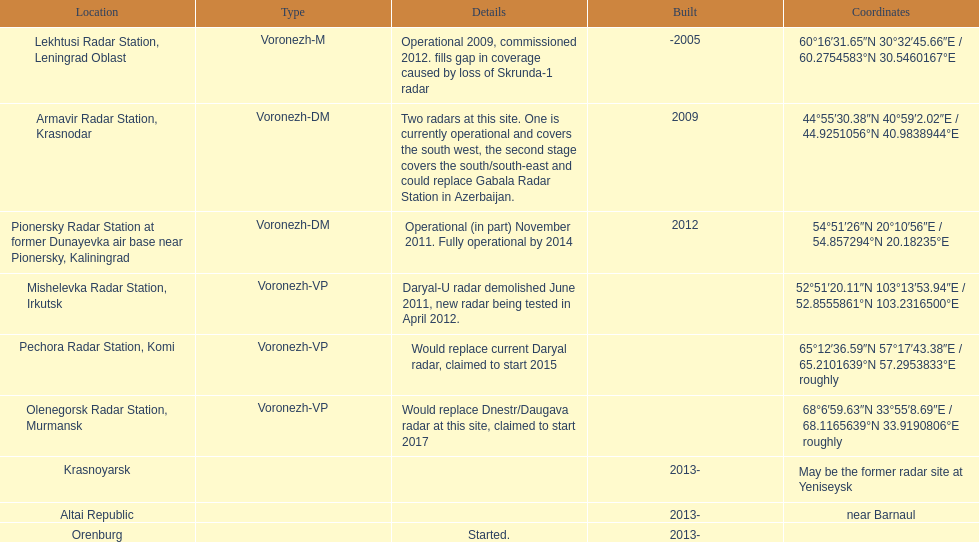Which site has the most radars? Armavir Radar Station, Krasnodar. 